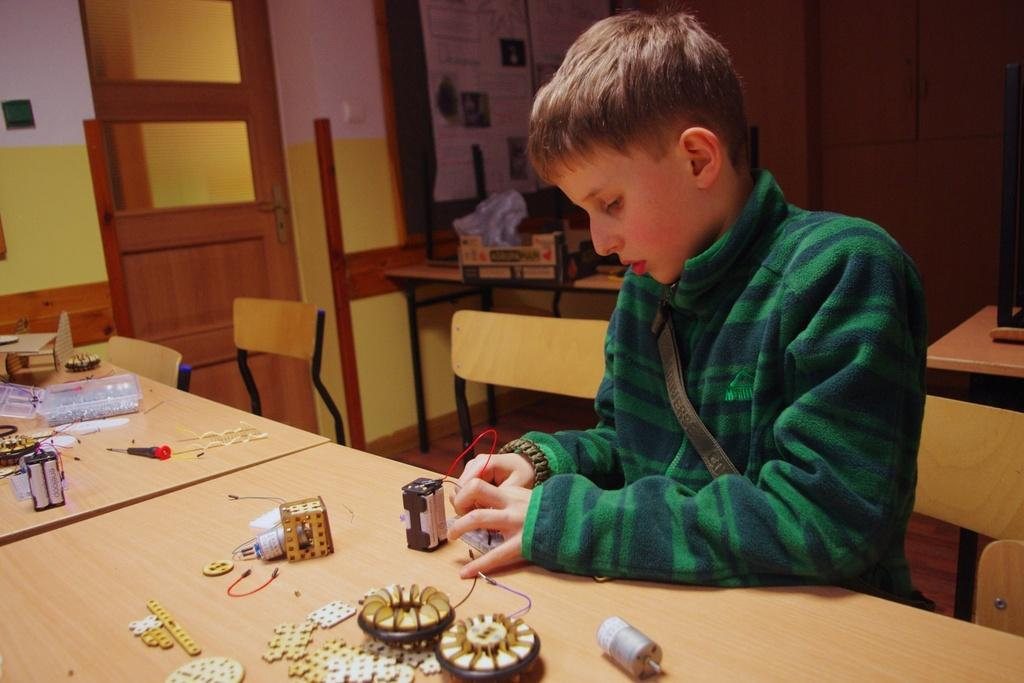What is the person in the image doing? The person is sitting on a chair in the image. What is the person doing while sitting on the chair? The person is doing something on a table. What can be seen in the background of the image? There is a door visible in the background of the image. Can you see the ocean in the image? No, there is no ocean present in the image. 